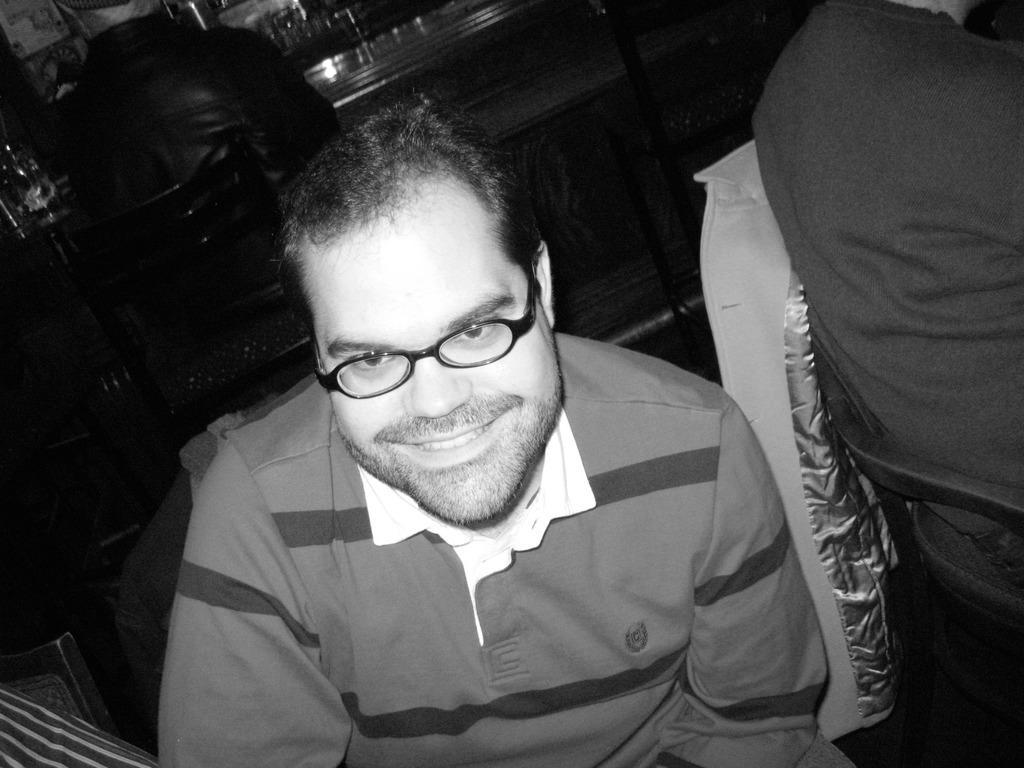Could you give a brief overview of what you see in this image? It is a black and white picture. In the center of the image we can see two persons are sitting. Among them, we can see one person is smiling and he is wearing glasses. At the bottom left side of the image, we can see some objects. In the background there is a wall and a few other objects. 